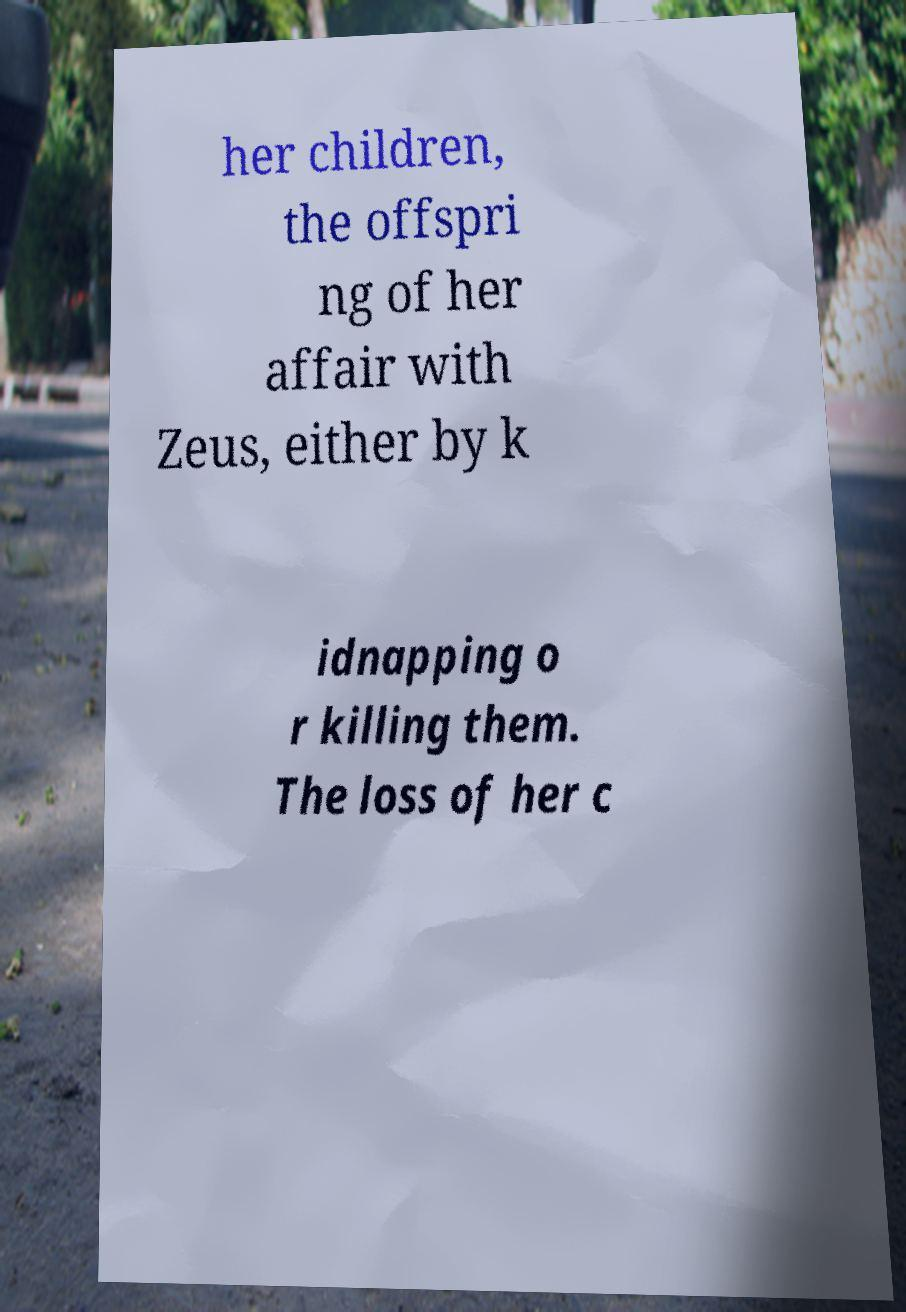There's text embedded in this image that I need extracted. Can you transcribe it verbatim? her children, the offspri ng of her affair with Zeus, either by k idnapping o r killing them. The loss of her c 